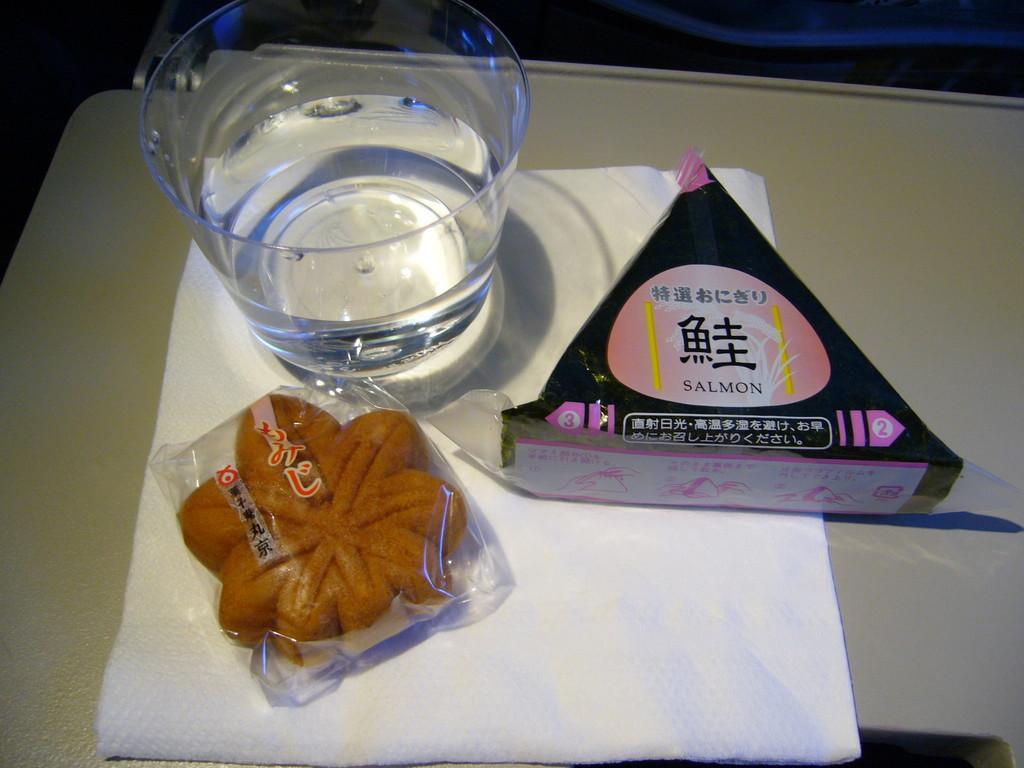Describe this image in one or two sentences. In this image we can see a few objects on a tissue paper. The tissue paper is placed on a white surface. 